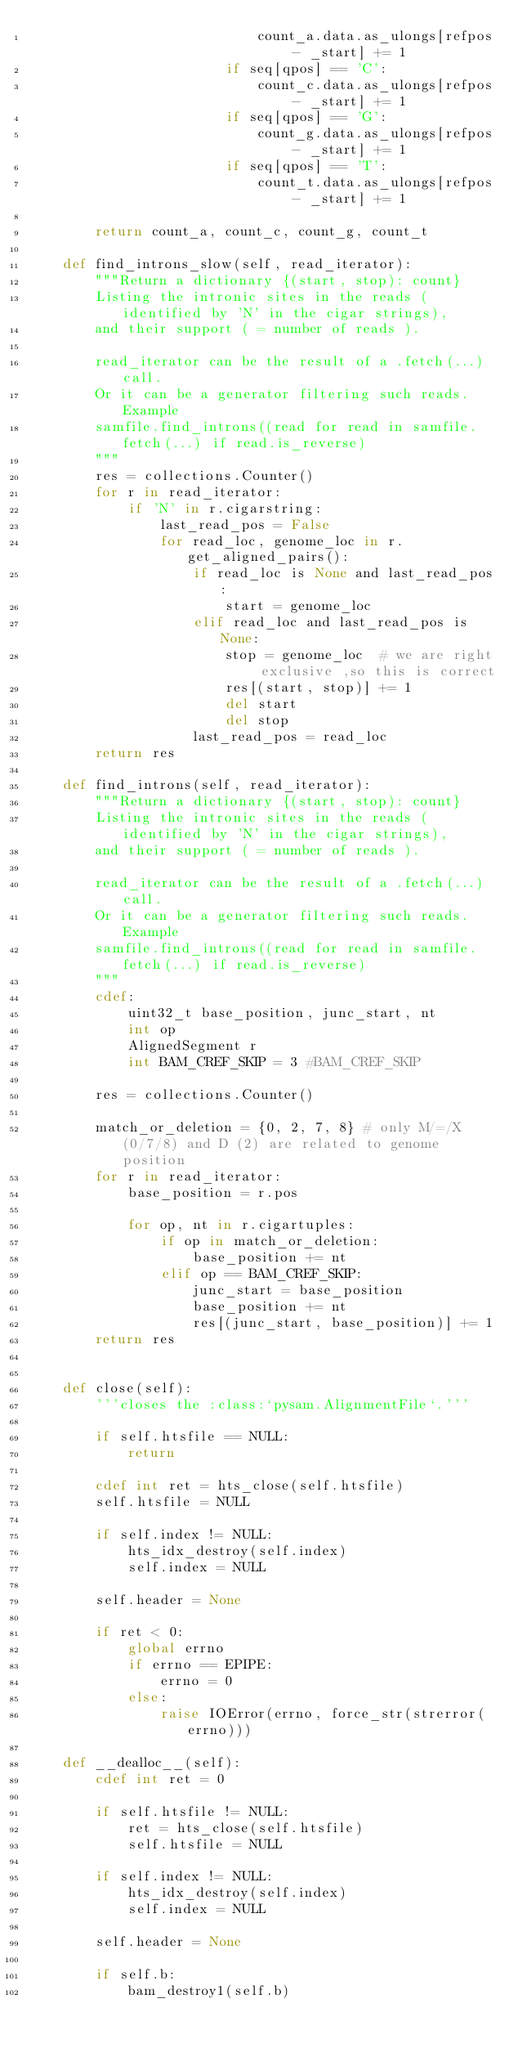<code> <loc_0><loc_0><loc_500><loc_500><_Cython_>                            count_a.data.as_ulongs[refpos - _start] += 1
                        if seq[qpos] == 'C':
                            count_c.data.as_ulongs[refpos - _start] += 1
                        if seq[qpos] == 'G':
                            count_g.data.as_ulongs[refpos - _start] += 1
                        if seq[qpos] == 'T':
                            count_t.data.as_ulongs[refpos - _start] += 1

        return count_a, count_c, count_g, count_t

    def find_introns_slow(self, read_iterator):
        """Return a dictionary {(start, stop): count}
        Listing the intronic sites in the reads (identified by 'N' in the cigar strings),
        and their support ( = number of reads ).

        read_iterator can be the result of a .fetch(...) call.
        Or it can be a generator filtering such reads. Example
        samfile.find_introns((read for read in samfile.fetch(...) if read.is_reverse)
        """
        res = collections.Counter()
        for r in read_iterator:
            if 'N' in r.cigarstring:
                last_read_pos = False
                for read_loc, genome_loc in r.get_aligned_pairs():
                    if read_loc is None and last_read_pos:
                        start = genome_loc
                    elif read_loc and last_read_pos is None:
                        stop = genome_loc  # we are right exclusive ,so this is correct
                        res[(start, stop)] += 1
                        del start
                        del stop
                    last_read_pos = read_loc
        return res

    def find_introns(self, read_iterator):
        """Return a dictionary {(start, stop): count}
        Listing the intronic sites in the reads (identified by 'N' in the cigar strings),
        and their support ( = number of reads ).

        read_iterator can be the result of a .fetch(...) call.
        Or it can be a generator filtering such reads. Example
        samfile.find_introns((read for read in samfile.fetch(...) if read.is_reverse)
        """
        cdef:
            uint32_t base_position, junc_start, nt
            int op
            AlignedSegment r
            int BAM_CREF_SKIP = 3 #BAM_CREF_SKIP

        res = collections.Counter()

        match_or_deletion = {0, 2, 7, 8} # only M/=/X (0/7/8) and D (2) are related to genome position
        for r in read_iterator:
            base_position = r.pos

            for op, nt in r.cigartuples:
                if op in match_or_deletion:
                    base_position += nt
                elif op == BAM_CREF_SKIP:
                    junc_start = base_position
                    base_position += nt
                    res[(junc_start, base_position)] += 1
        return res


    def close(self):
        '''closes the :class:`pysam.AlignmentFile`.'''

        if self.htsfile == NULL:
            return

        cdef int ret = hts_close(self.htsfile)
        self.htsfile = NULL

        if self.index != NULL:
            hts_idx_destroy(self.index)
            self.index = NULL

        self.header = None

        if ret < 0:
            global errno
            if errno == EPIPE:
                errno = 0
            else:
                raise IOError(errno, force_str(strerror(errno)))

    def __dealloc__(self):
        cdef int ret = 0

        if self.htsfile != NULL:
            ret = hts_close(self.htsfile)
            self.htsfile = NULL

        if self.index != NULL:
            hts_idx_destroy(self.index)
            self.index = NULL

        self.header = None

        if self.b:
            bam_destroy1(self.b)</code> 